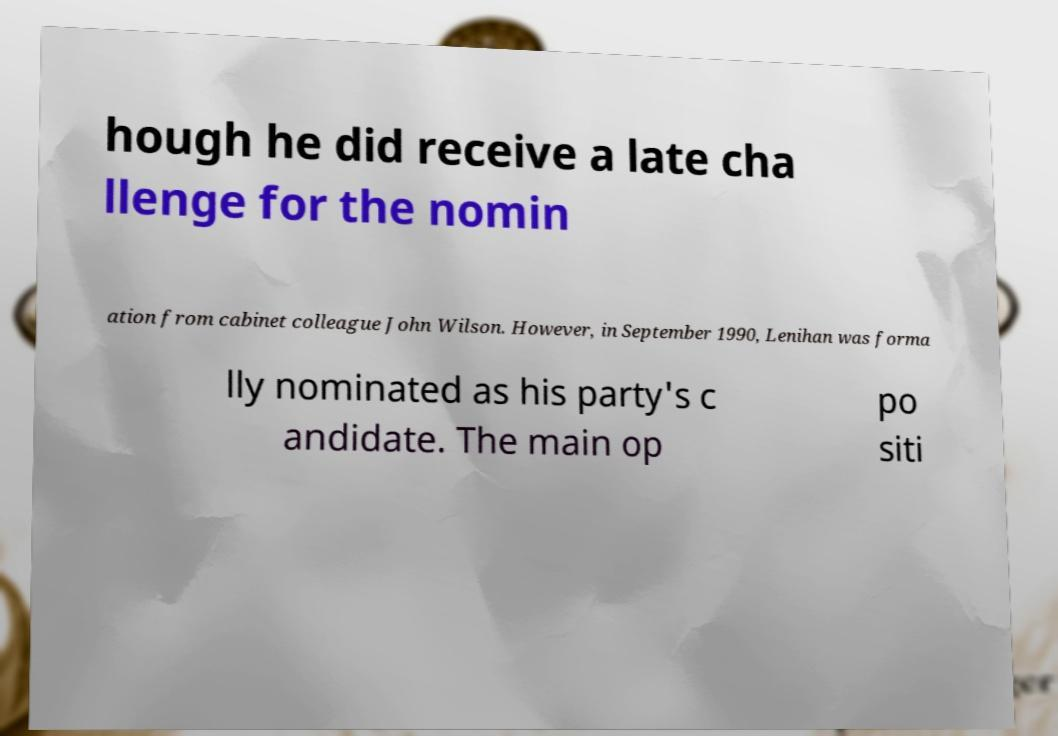Can you read and provide the text displayed in the image?This photo seems to have some interesting text. Can you extract and type it out for me? hough he did receive a late cha llenge for the nomin ation from cabinet colleague John Wilson. However, in September 1990, Lenihan was forma lly nominated as his party's c andidate. The main op po siti 